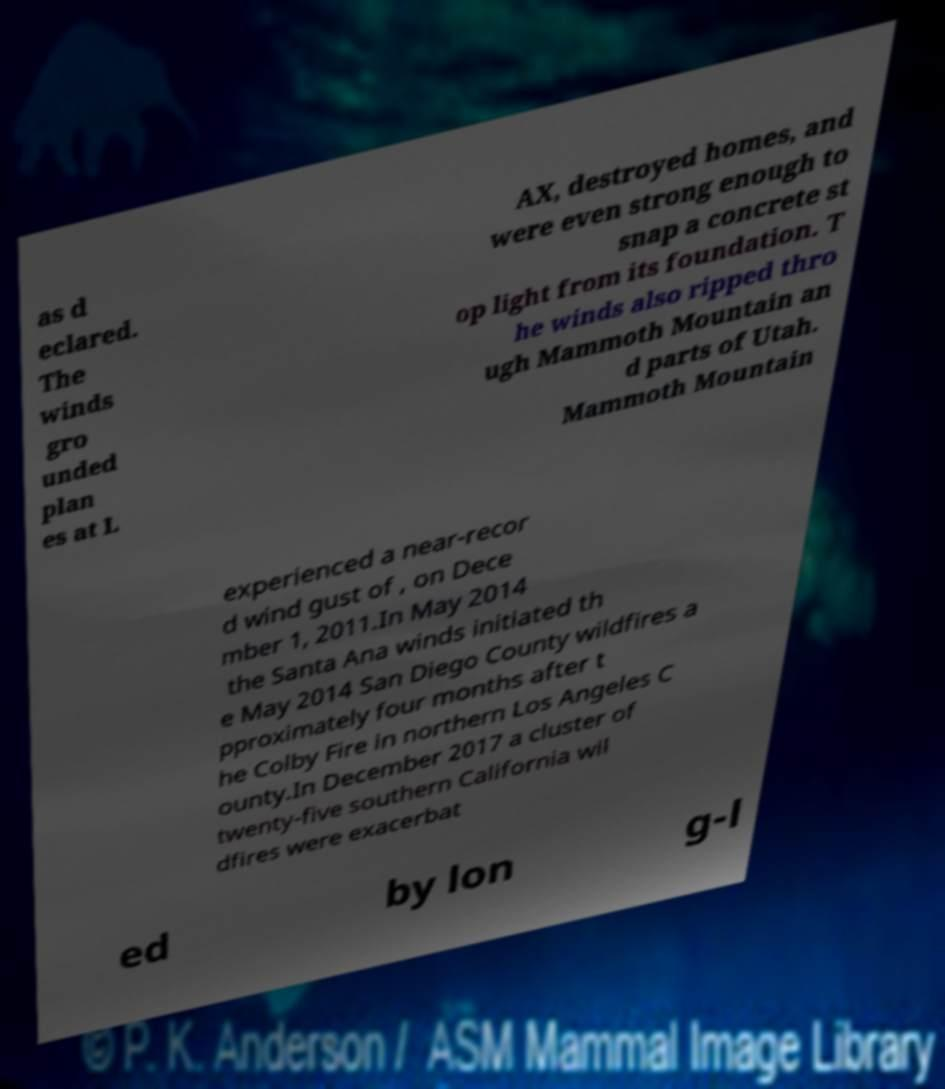I need the written content from this picture converted into text. Can you do that? as d eclared. The winds gro unded plan es at L AX, destroyed homes, and were even strong enough to snap a concrete st op light from its foundation. T he winds also ripped thro ugh Mammoth Mountain an d parts of Utah. Mammoth Mountain experienced a near-recor d wind gust of , on Dece mber 1, 2011.In May 2014 the Santa Ana winds initiated th e May 2014 San Diego County wildfires a pproximately four months after t he Colby Fire in northern Los Angeles C ounty.In December 2017 a cluster of twenty-five southern California wil dfires were exacerbat ed by lon g-l 